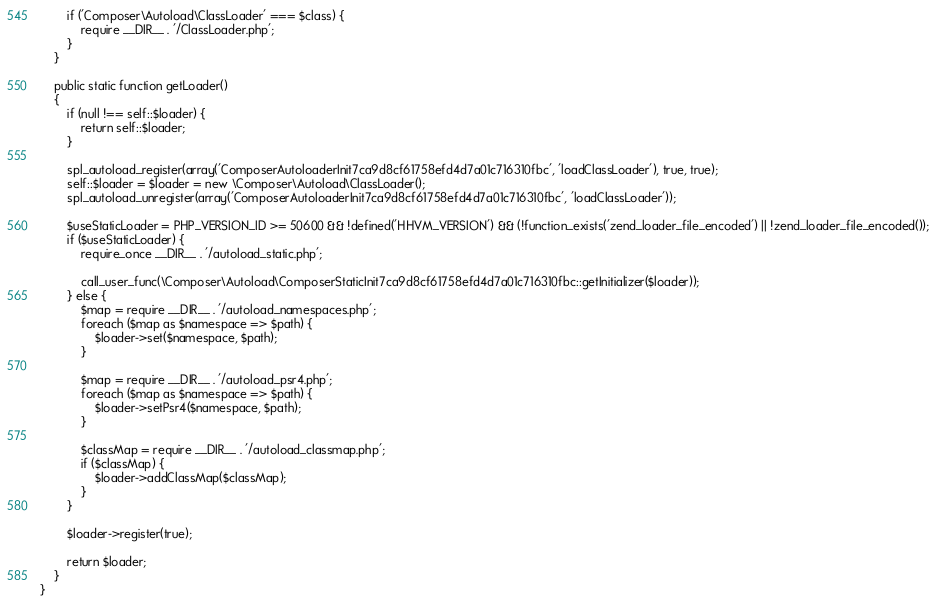<code> <loc_0><loc_0><loc_500><loc_500><_PHP_>        if ('Composer\Autoload\ClassLoader' === $class) {
            require __DIR__ . '/ClassLoader.php';
        }
    }

    public static function getLoader()
    {
        if (null !== self::$loader) {
            return self::$loader;
        }

        spl_autoload_register(array('ComposerAutoloaderInit7ca9d8cf61758efd4d7a01c716310fbc', 'loadClassLoader'), true, true);
        self::$loader = $loader = new \Composer\Autoload\ClassLoader();
        spl_autoload_unregister(array('ComposerAutoloaderInit7ca9d8cf61758efd4d7a01c716310fbc', 'loadClassLoader'));

        $useStaticLoader = PHP_VERSION_ID >= 50600 && !defined('HHVM_VERSION') && (!function_exists('zend_loader_file_encoded') || !zend_loader_file_encoded());
        if ($useStaticLoader) {
            require_once __DIR__ . '/autoload_static.php';

            call_user_func(\Composer\Autoload\ComposerStaticInit7ca9d8cf61758efd4d7a01c716310fbc::getInitializer($loader));
        } else {
            $map = require __DIR__ . '/autoload_namespaces.php';
            foreach ($map as $namespace => $path) {
                $loader->set($namespace, $path);
            }

            $map = require __DIR__ . '/autoload_psr4.php';
            foreach ($map as $namespace => $path) {
                $loader->setPsr4($namespace, $path);
            }

            $classMap = require __DIR__ . '/autoload_classmap.php';
            if ($classMap) {
                $loader->addClassMap($classMap);
            }
        }

        $loader->register(true);

        return $loader;
    }
}
</code> 